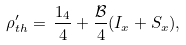Convert formula to latex. <formula><loc_0><loc_0><loc_500><loc_500>\rho _ { t h } ^ { \prime } = \, \frac { 1 _ { 4 } } { 4 } + \frac { \mathcal { B } } { 4 } ( I _ { x } + S _ { x } ) ,</formula> 